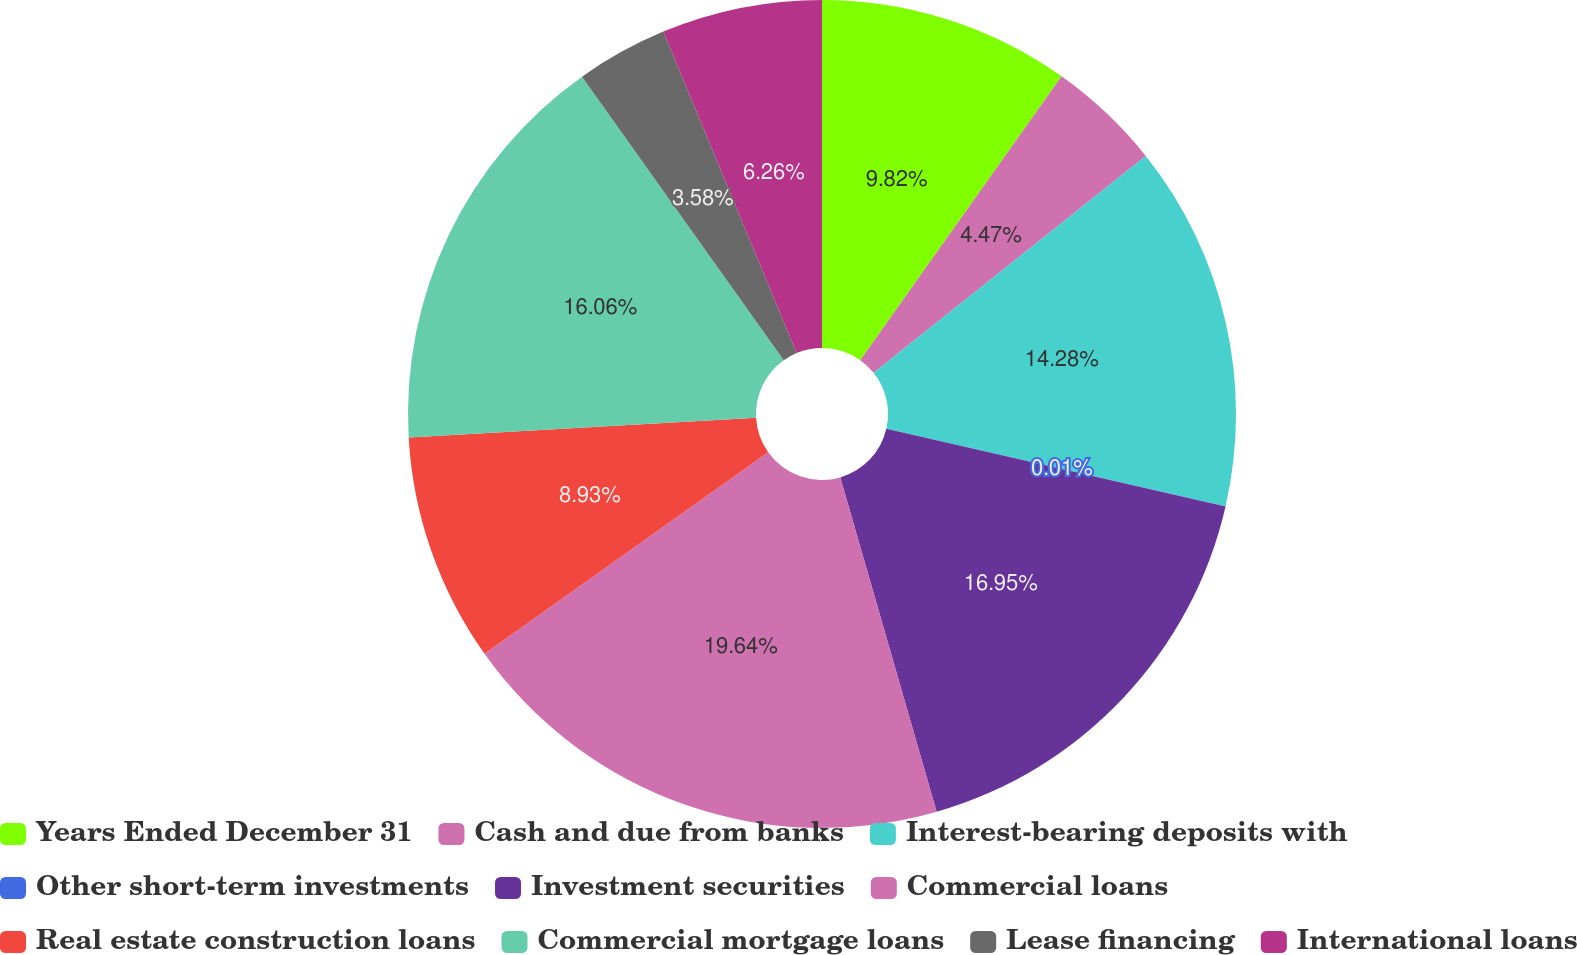<chart> <loc_0><loc_0><loc_500><loc_500><pie_chart><fcel>Years Ended December 31<fcel>Cash and due from banks<fcel>Interest-bearing deposits with<fcel>Other short-term investments<fcel>Investment securities<fcel>Commercial loans<fcel>Real estate construction loans<fcel>Commercial mortgage loans<fcel>Lease financing<fcel>International loans<nl><fcel>9.82%<fcel>4.47%<fcel>14.28%<fcel>0.01%<fcel>16.95%<fcel>19.63%<fcel>8.93%<fcel>16.06%<fcel>3.58%<fcel>6.26%<nl></chart> 